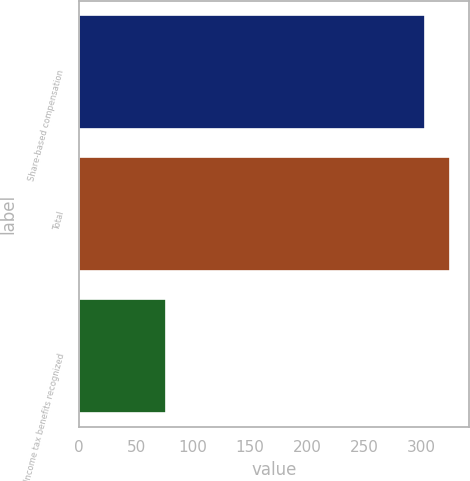Convert chart. <chart><loc_0><loc_0><loc_500><loc_500><bar_chart><fcel>Share-based compensation<fcel>Total<fcel>Income tax benefits recognized<nl><fcel>303<fcel>325.7<fcel>76<nl></chart> 